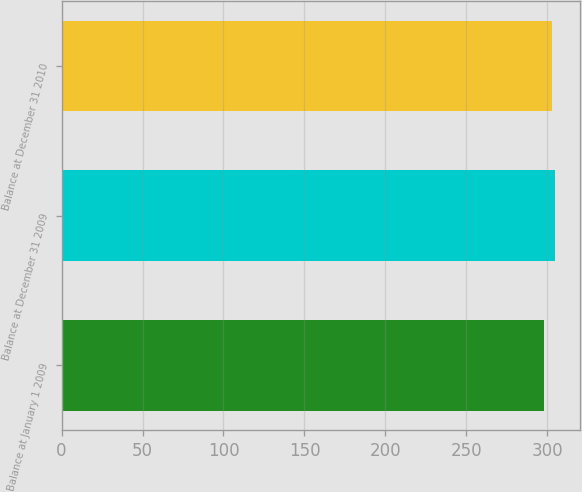<chart> <loc_0><loc_0><loc_500><loc_500><bar_chart><fcel>Balance at January 1 2009<fcel>Balance at December 31 2009<fcel>Balance at December 31 2010<nl><fcel>298<fcel>305<fcel>303<nl></chart> 